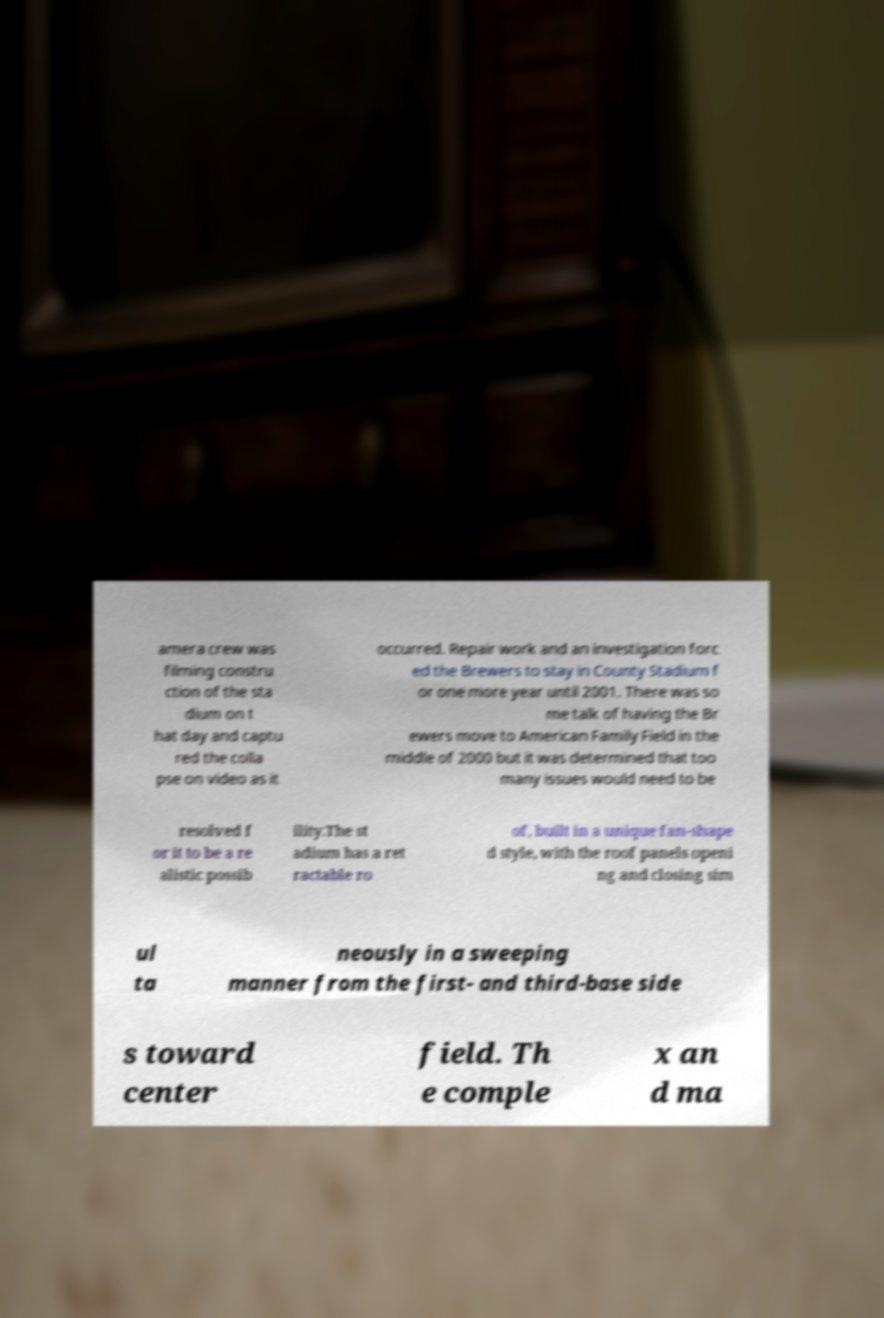Please identify and transcribe the text found in this image. amera crew was filming constru ction of the sta dium on t hat day and captu red the colla pse on video as it occurred. Repair work and an investigation forc ed the Brewers to stay in County Stadium f or one more year until 2001. There was so me talk of having the Br ewers move to American Family Field in the middle of 2000 but it was determined that too many issues would need to be resolved f or it to be a re alistic possib ility.The st adium has a ret ractable ro of, built in a unique fan-shape d style, with the roof panels openi ng and closing sim ul ta neously in a sweeping manner from the first- and third-base side s toward center field. Th e comple x an d ma 